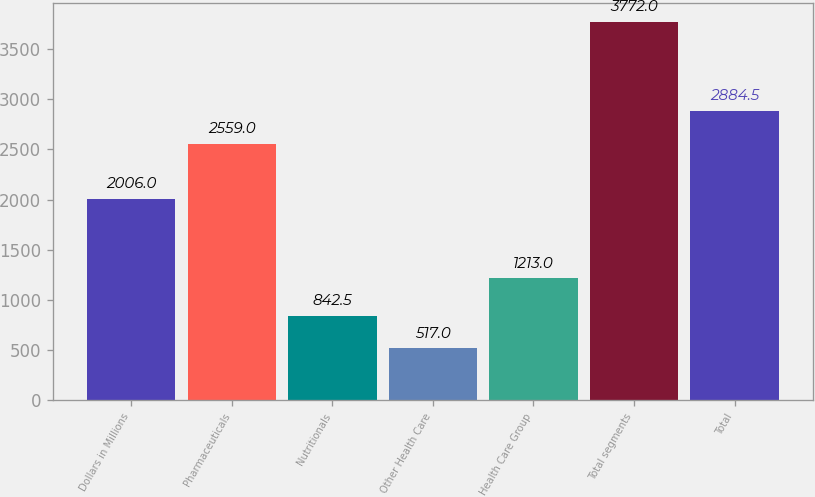Convert chart. <chart><loc_0><loc_0><loc_500><loc_500><bar_chart><fcel>Dollars in Millions<fcel>Pharmaceuticals<fcel>Nutritionals<fcel>Other Health Care<fcel>Health Care Group<fcel>Total segments<fcel>Total<nl><fcel>2006<fcel>2559<fcel>842.5<fcel>517<fcel>1213<fcel>3772<fcel>2884.5<nl></chart> 